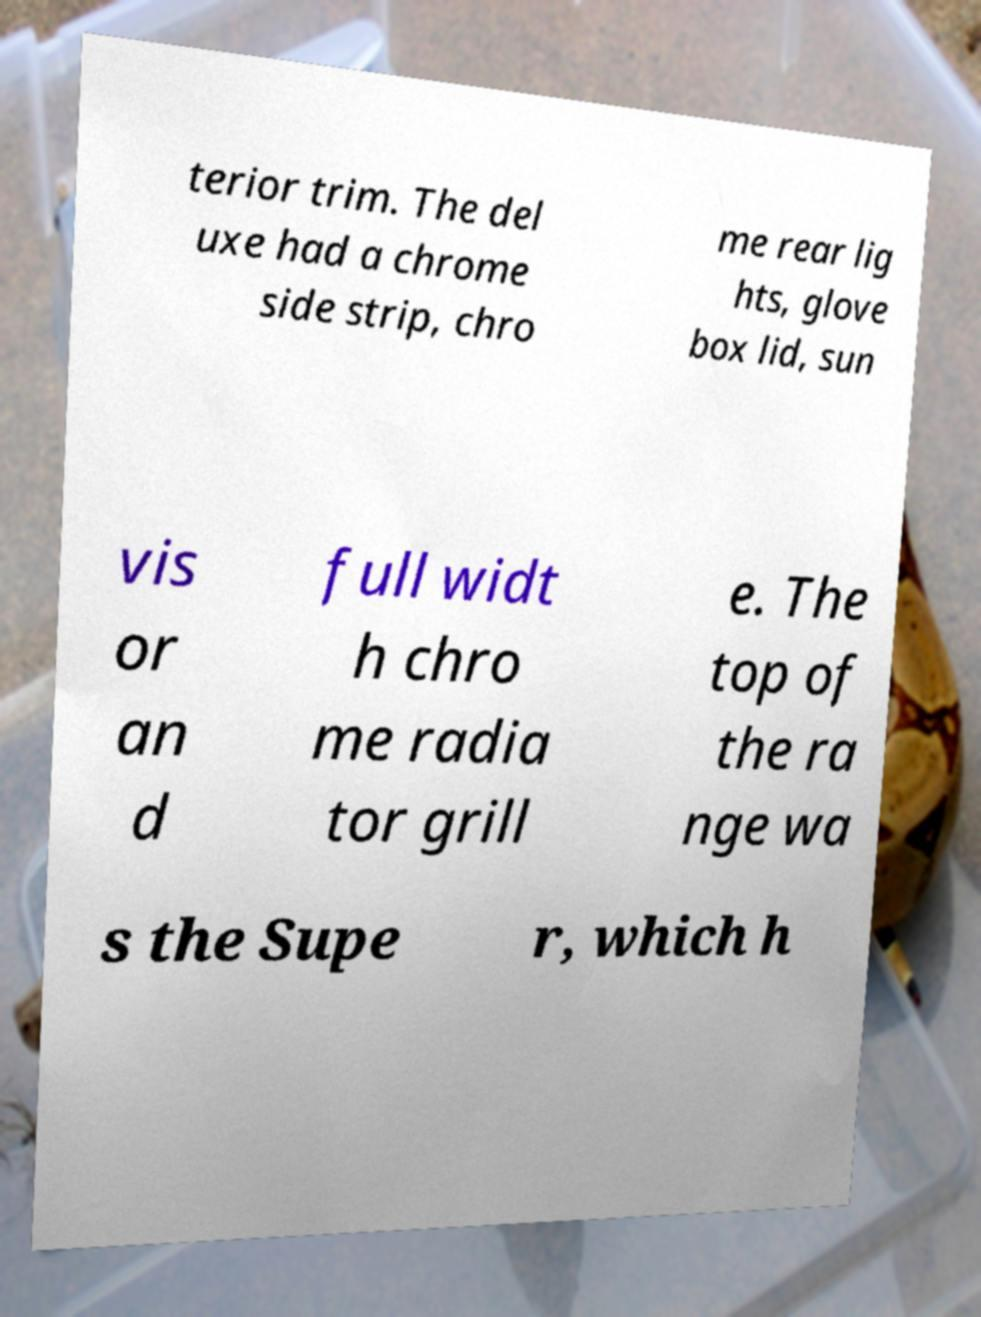Can you accurately transcribe the text from the provided image for me? terior trim. The del uxe had a chrome side strip, chro me rear lig hts, glove box lid, sun vis or an d full widt h chro me radia tor grill e. The top of the ra nge wa s the Supe r, which h 